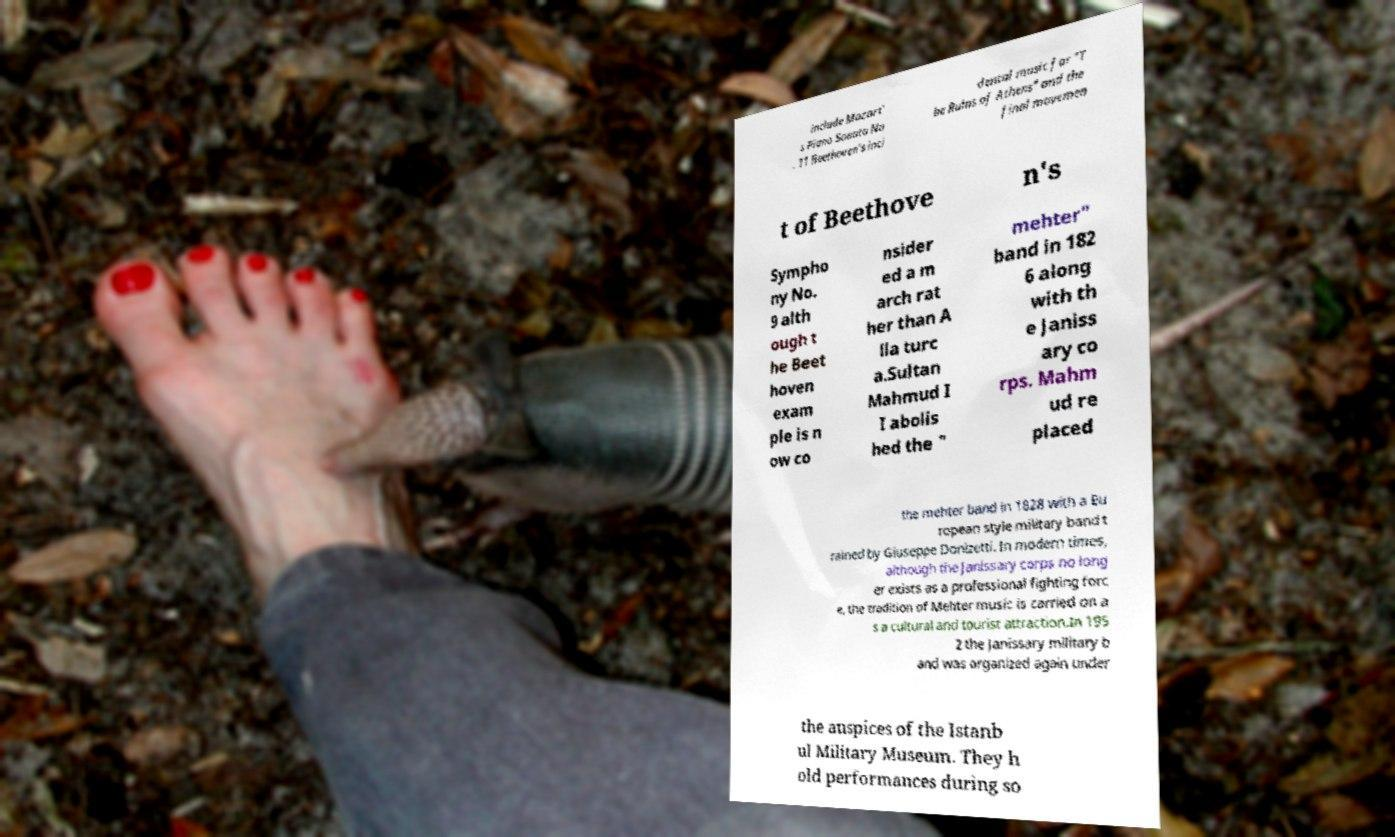There's text embedded in this image that I need extracted. Can you transcribe it verbatim? include Mozart' s Piano Sonata No . 11 Beethoven's inci dental music for "T he Ruins of Athens" and the final movemen t of Beethove n's Sympho ny No. 9 alth ough t he Beet hoven exam ple is n ow co nsider ed a m arch rat her than A lla turc a.Sultan Mahmud I I abolis hed the " mehter" band in 182 6 along with th e Janiss ary co rps. Mahm ud re placed the mehter band in 1828 with a Eu ropean style military band t rained by Giuseppe Donizetti. In modern times, although the Janissary corps no long er exists as a professional fighting forc e, the tradition of Mehter music is carried on a s a cultural and tourist attraction.In 195 2 the Janissary military b and was organized again under the auspices of the Istanb ul Military Museum. They h old performances during so 